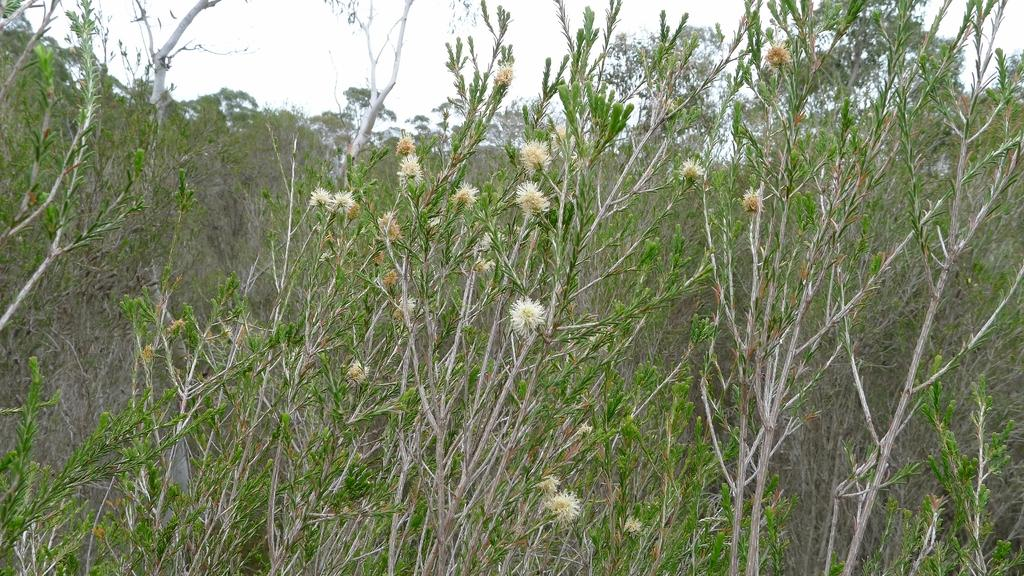What type of living organisms can be seen in the image? Plants and flowers are visible in the image. What part of the natural environment is visible in the image? The sky is visible at the top of the image. What type of metal support can be seen holding up the flowers in the image? There is no metal support visible in the image; the flowers are not being held up by any visible structure. 